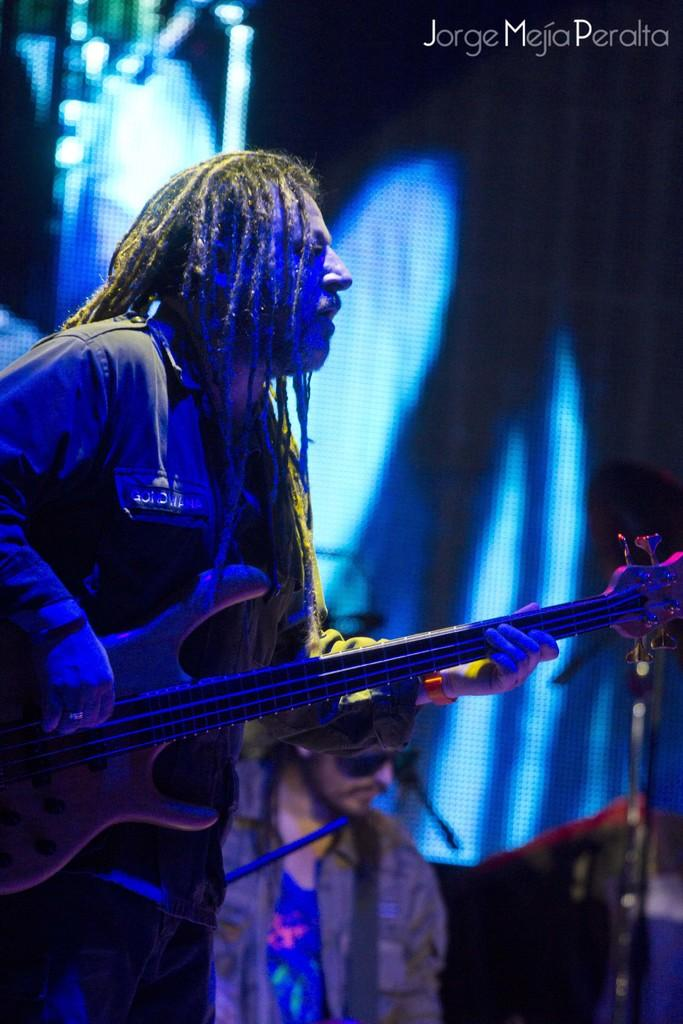Who is the main subject in the image? There is a man in the image. What is the man doing in the image? The man is playing a guitar. Can you describe the setting of the image? The setting is a rock concert. How many spies are present in the image? There are no spies present in the image; it features a man playing a guitar at a rock concert. 